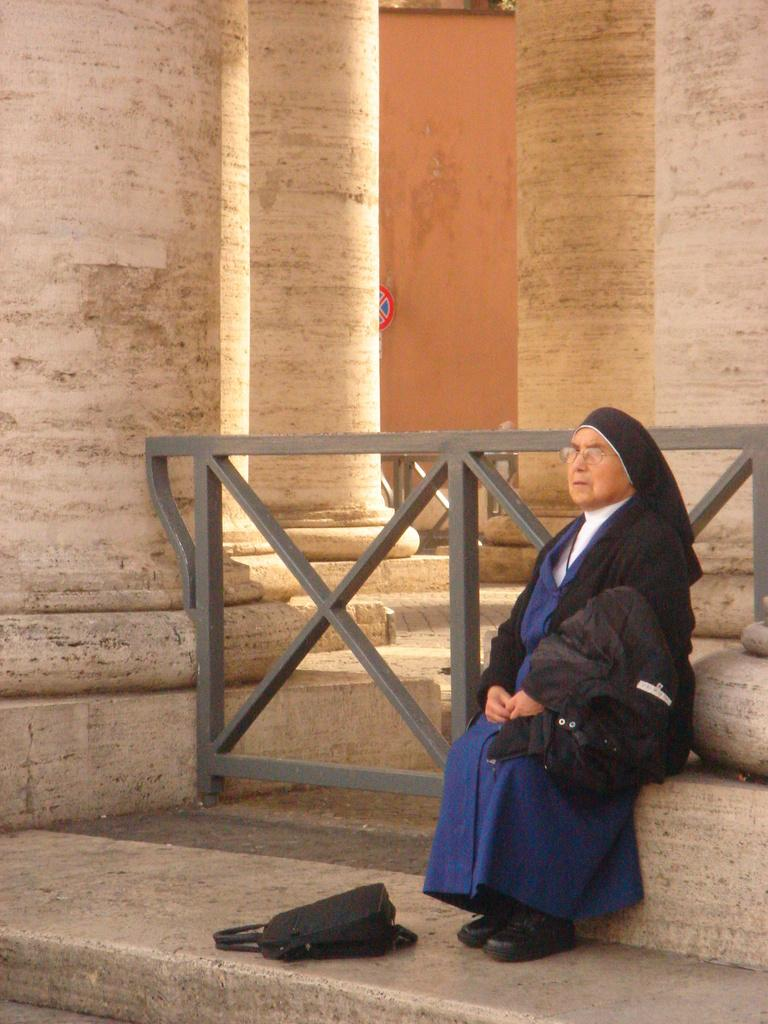Who is present in the image? There is a woman in the image. What is the woman wearing? The woman is wearing a blue and black dress. What object can be seen on the floor in the image? There is a bag on the floor in the image. What architectural feature can be seen in the background of the image? There are pillars in the background of the image. What type of animal is the woman painting in the image? There is no animal present in the image, nor is there any indication that the woman is painting. 